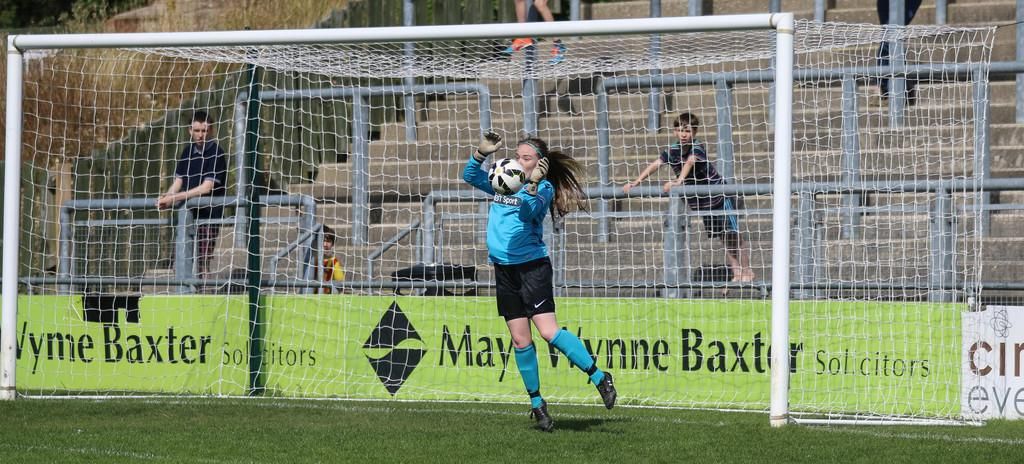<image>
Present a compact description of the photo's key features. A goalkeeper catches a soccer ball behind a banner sponsored by May Wynne Baxter Solicitors. 